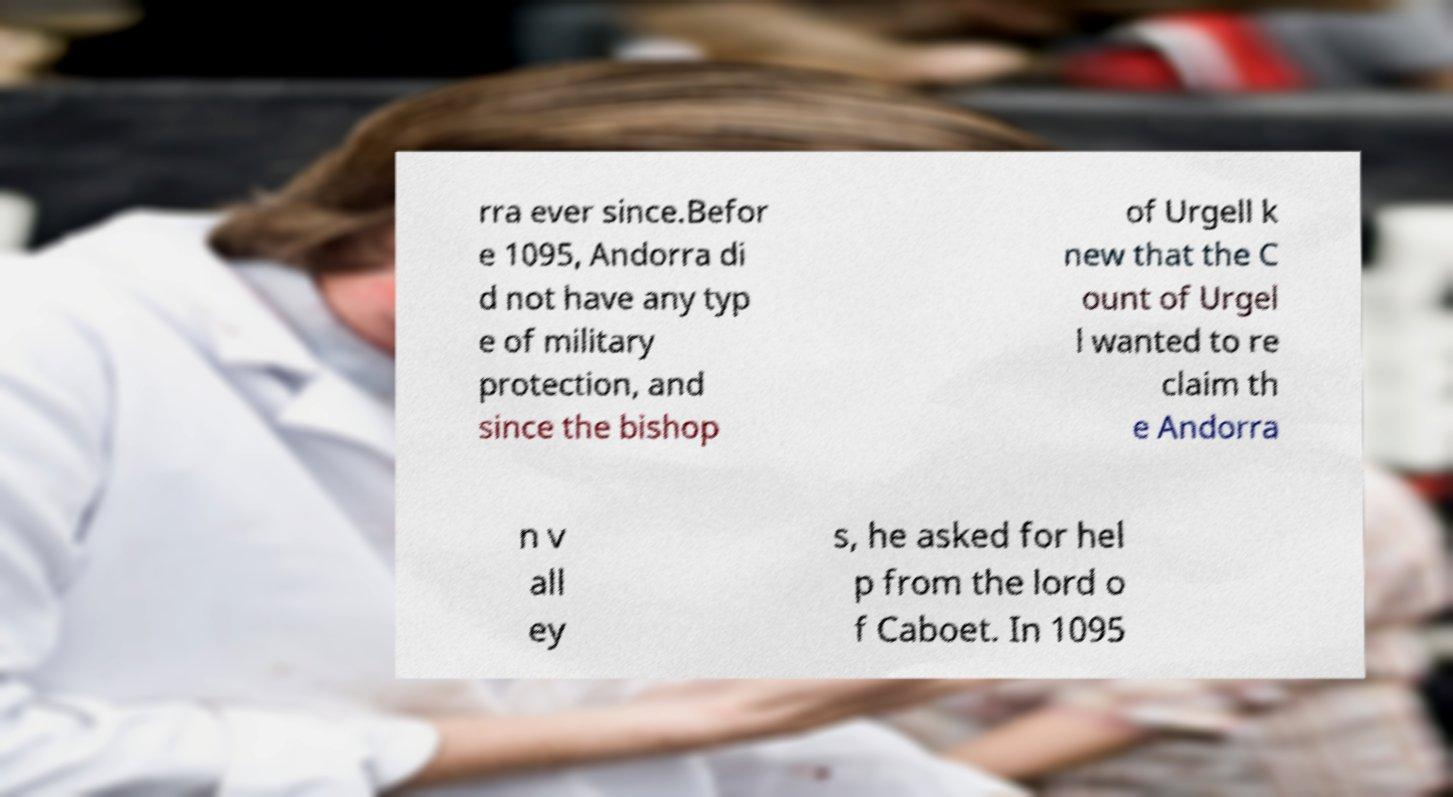I need the written content from this picture converted into text. Can you do that? rra ever since.Befor e 1095, Andorra di d not have any typ e of military protection, and since the bishop of Urgell k new that the C ount of Urgel l wanted to re claim th e Andorra n v all ey s, he asked for hel p from the lord o f Caboet. In 1095 